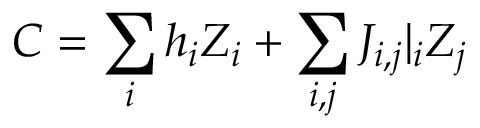<formula> <loc_0><loc_0><loc_500><loc_500>C = \sum _ { i } h _ { i } Z _ { i } + \sum _ { i , j } J _ { i , j } | _ { i } Z _ { j }</formula> 